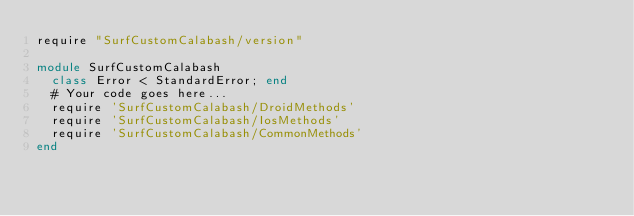<code> <loc_0><loc_0><loc_500><loc_500><_Ruby_>require "SurfCustomCalabash/version"

module SurfCustomCalabash
  class Error < StandardError; end
  # Your code goes here...
  require 'SurfCustomCalabash/DroidMethods'
  require 'SurfCustomCalabash/IosMethods'
  require 'SurfCustomCalabash/CommonMethods'
end
</code> 